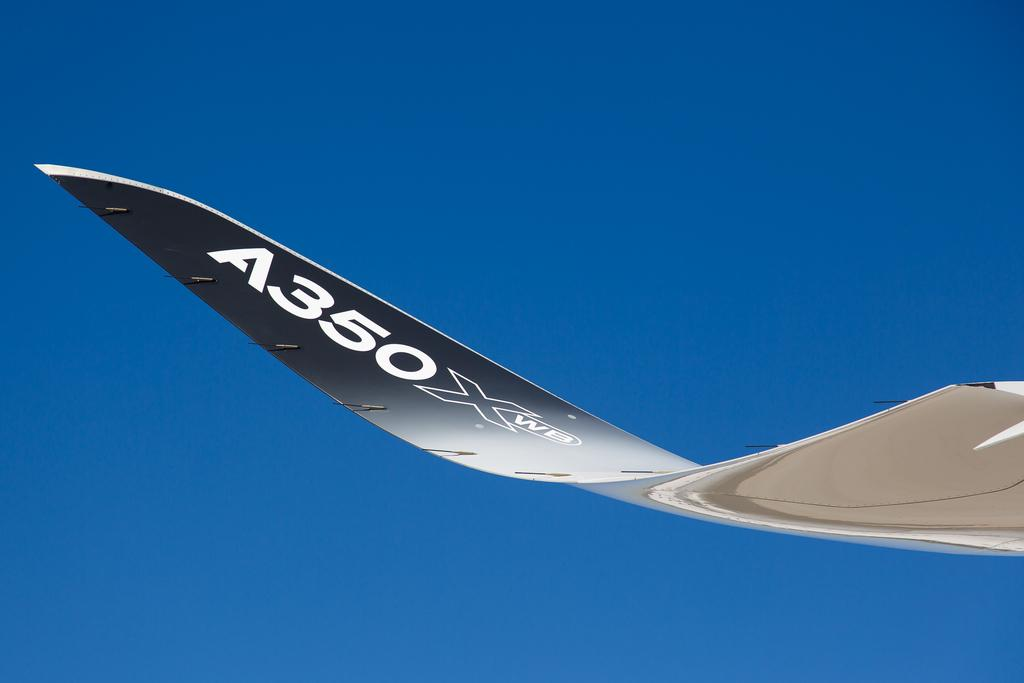<image>
Offer a succinct explanation of the picture presented. A wing of an airplane has the identifier A350 XWB on it. 